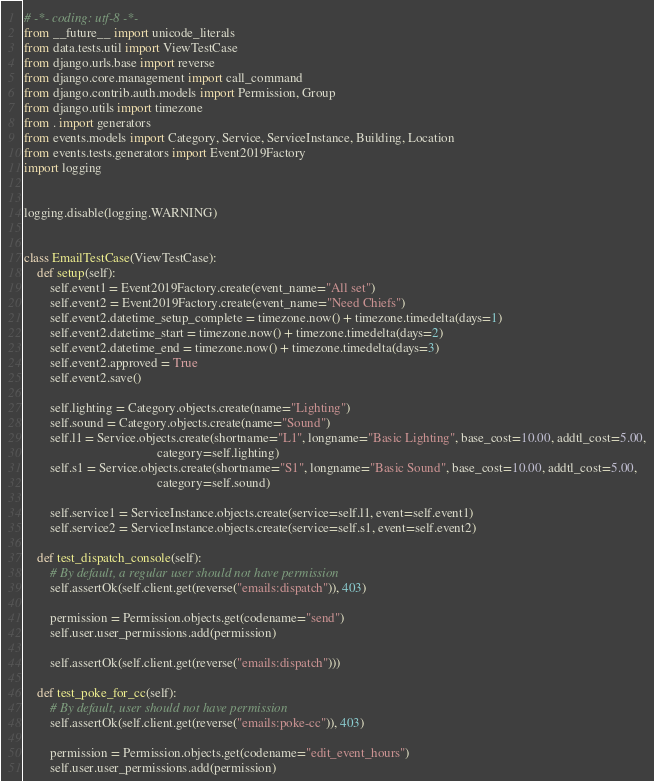Convert code to text. <code><loc_0><loc_0><loc_500><loc_500><_Python_># -*- coding: utf-8 -*-
from __future__ import unicode_literals
from data.tests.util import ViewTestCase
from django.urls.base import reverse
from django.core.management import call_command
from django.contrib.auth.models import Permission, Group
from django.utils import timezone
from . import generators
from events.models import Category, Service, ServiceInstance, Building, Location
from events.tests.generators import Event2019Factory
import logging


logging.disable(logging.WARNING)


class EmailTestCase(ViewTestCase):
    def setup(self):
        self.event1 = Event2019Factory.create(event_name="All set")
        self.event2 = Event2019Factory.create(event_name="Need Chiefs")
        self.event2.datetime_setup_complete = timezone.now() + timezone.timedelta(days=1)
        self.event2.datetime_start = timezone.now() + timezone.timedelta(days=2)
        self.event2.datetime_end = timezone.now() + timezone.timedelta(days=3)
        self.event2.approved = True
        self.event2.save()

        self.lighting = Category.objects.create(name="Lighting")
        self.sound = Category.objects.create(name="Sound")
        self.l1 = Service.objects.create(shortname="L1", longname="Basic Lighting", base_cost=10.00, addtl_cost=5.00,
                                         category=self.lighting)
        self.s1 = Service.objects.create(shortname="S1", longname="Basic Sound", base_cost=10.00, addtl_cost=5.00,
                                         category=self.sound)

        self.service1 = ServiceInstance.objects.create(service=self.l1, event=self.event1)
        self.service2 = ServiceInstance.objects.create(service=self.s1, event=self.event2)

    def test_dispatch_console(self):
        # By default, a regular user should not have permission
        self.assertOk(self.client.get(reverse("emails:dispatch")), 403)

        permission = Permission.objects.get(codename="send")
        self.user.user_permissions.add(permission)

        self.assertOk(self.client.get(reverse("emails:dispatch")))

    def test_poke_for_cc(self):
        # By default, user should not have permission
        self.assertOk(self.client.get(reverse("emails:poke-cc")), 403)

        permission = Permission.objects.get(codename="edit_event_hours")
        self.user.user_permissions.add(permission)
</code> 